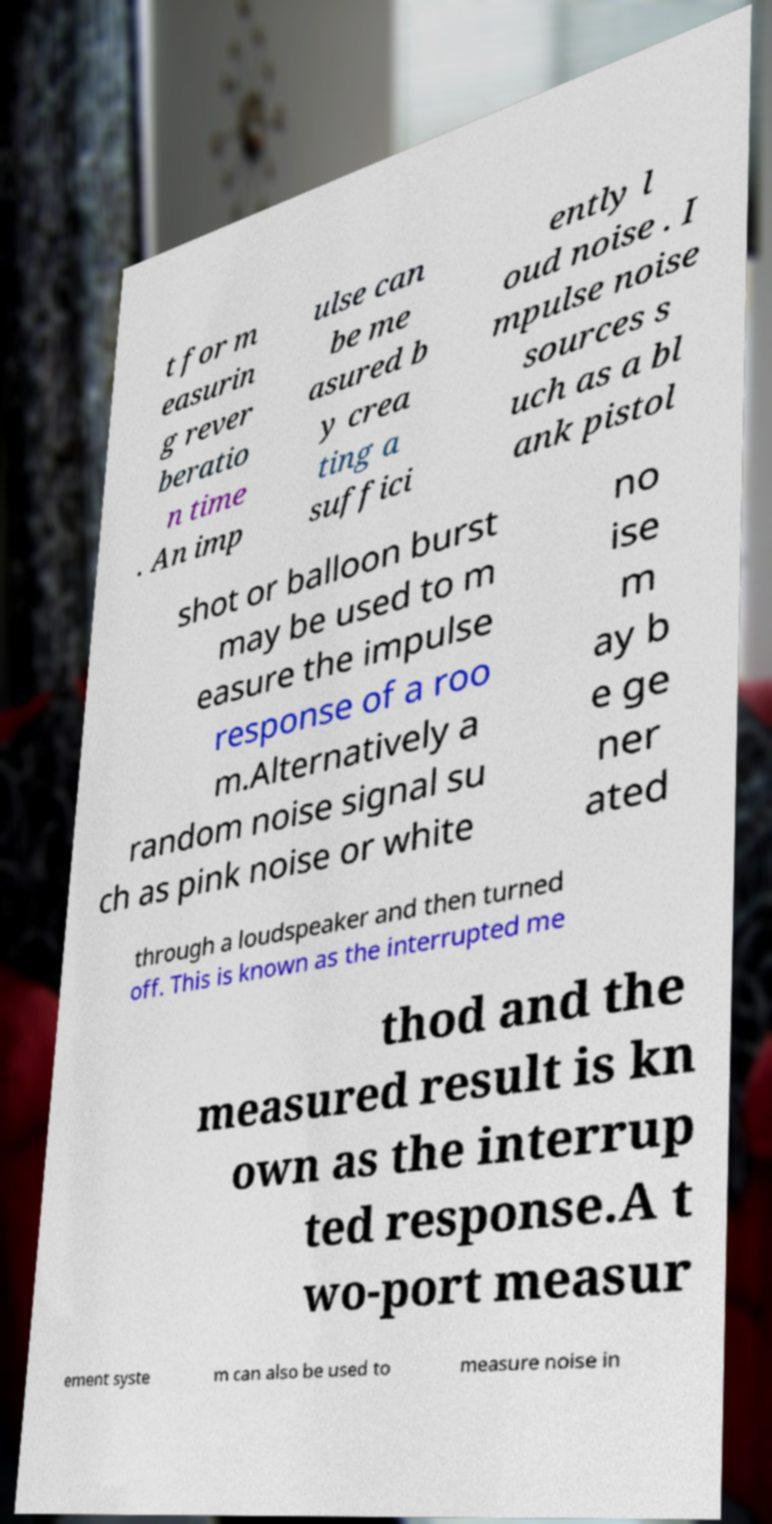I need the written content from this picture converted into text. Can you do that? t for m easurin g rever beratio n time . An imp ulse can be me asured b y crea ting a suffici ently l oud noise . I mpulse noise sources s uch as a bl ank pistol shot or balloon burst may be used to m easure the impulse response of a roo m.Alternatively a random noise signal su ch as pink noise or white no ise m ay b e ge ner ated through a loudspeaker and then turned off. This is known as the interrupted me thod and the measured result is kn own as the interrup ted response.A t wo-port measur ement syste m can also be used to measure noise in 